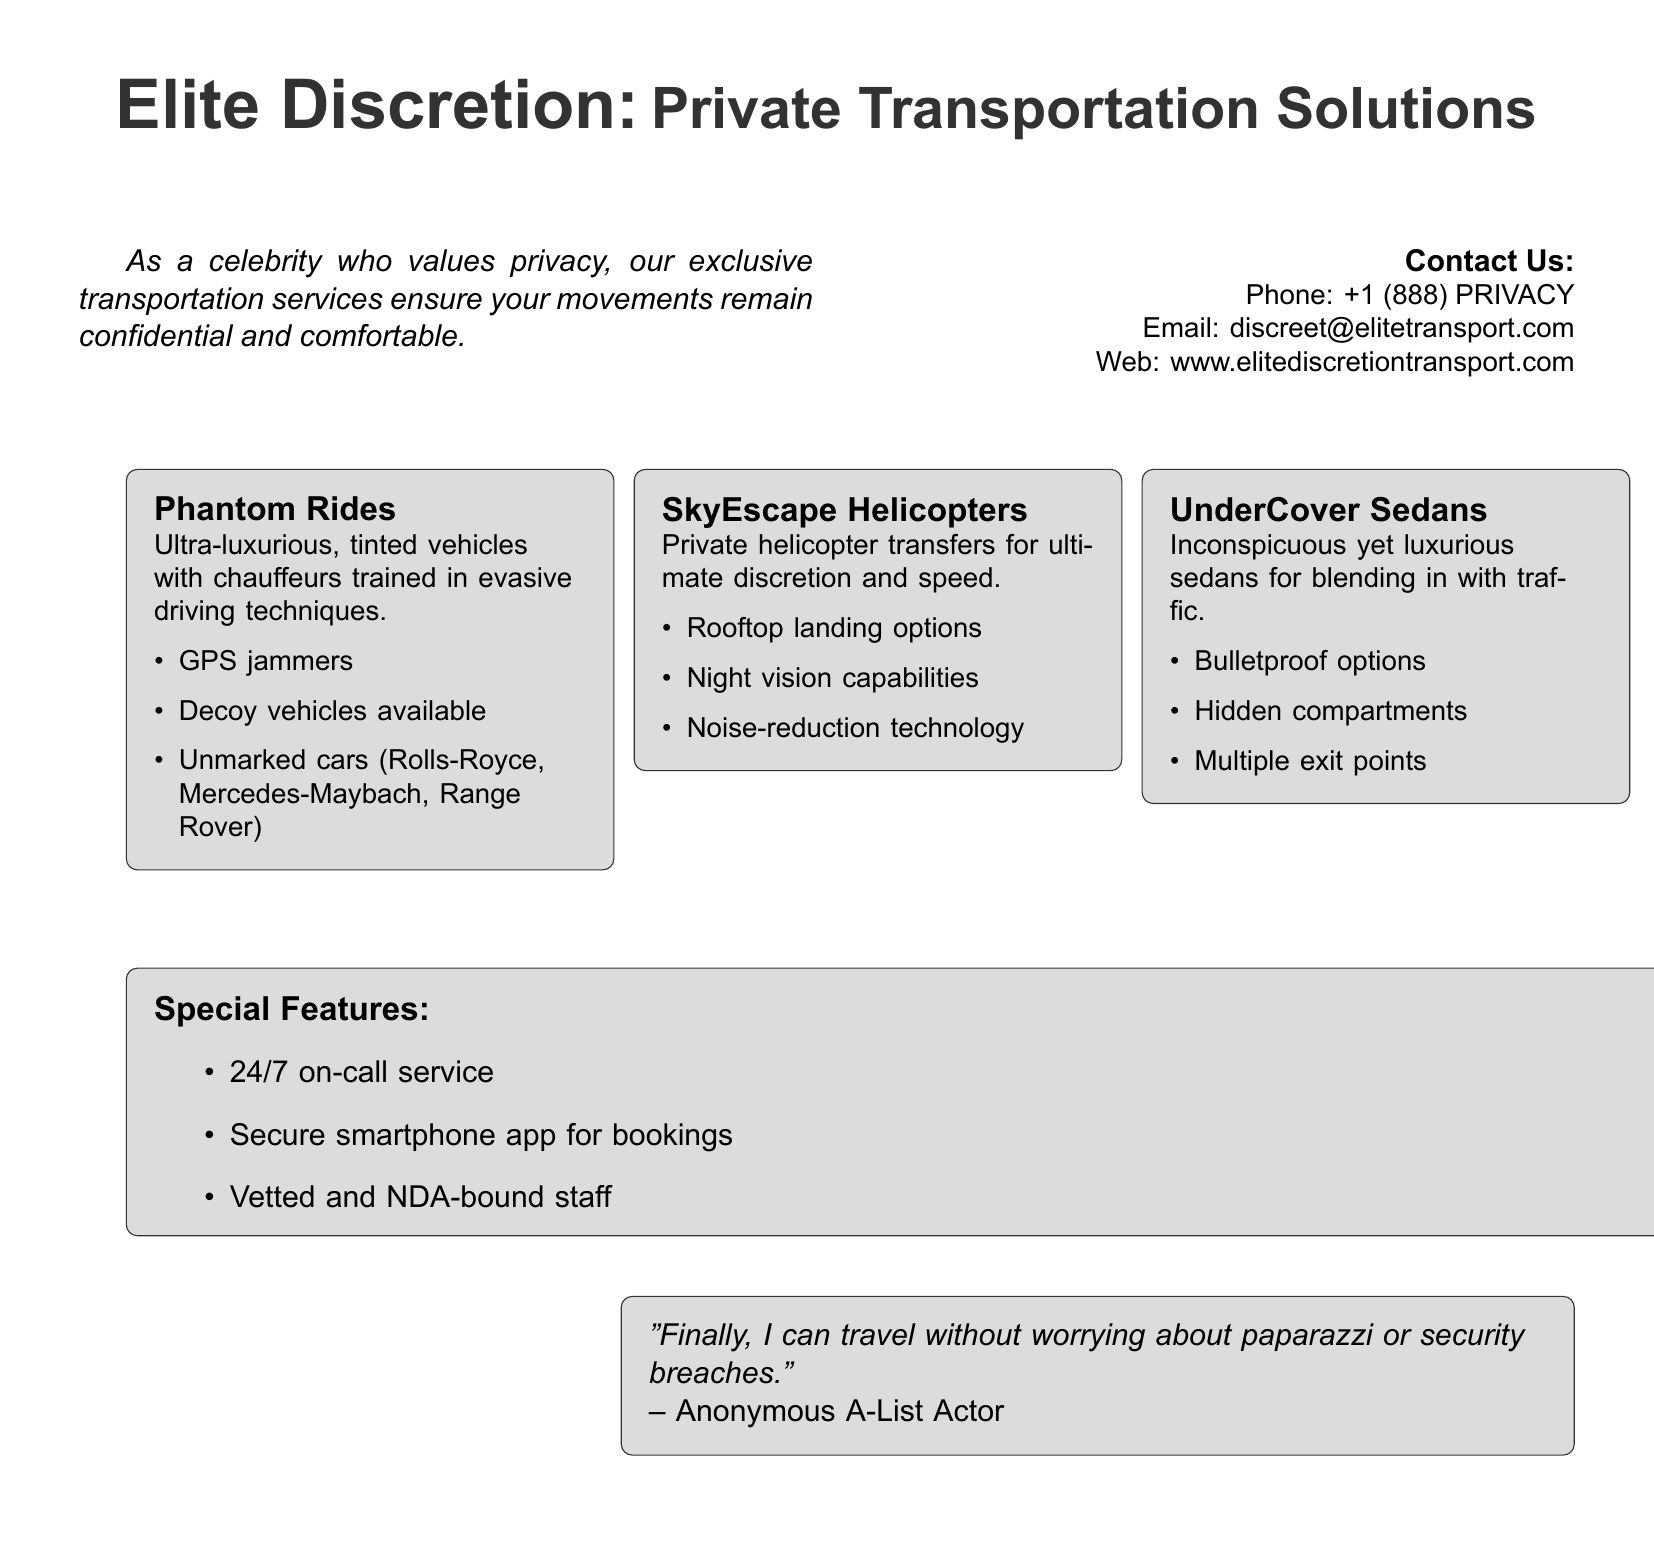What is the name of the transportation service? The name of the transportation service is found at the top of the document, which is "Elite Discretion: Private Transportation Solutions."
Answer: Elite Discretion: Private Transportation Solutions What is the contact phone number provided? The contact phone number is listed under the contact information section in the document.
Answer: +1 (888) PRIVACY What type of vehicles does the Phantom Rides service use? The Phantom Rides service uses ultra-luxurious, tinted vehicles, which include specific brands mentioned in the document.
Answer: Rolls-Royce, Mercedes-Maybach, Range Rover What unique feature does SkyEscape Helicopters offer? The SkyEscape Helicopters service is described with a specific unique feature related to its operational capabilities.
Answer: Rooftop landing options How many primary services are listed in the document? The document lists three primary services in the transportation solutions section.
Answer: 3 What is the special feature of the transportation service available 24/7? The special feature that is available 24/7 is mentioned in the "Special Features" section of the document.
Answer: 24/7 on-call service What is a requirement for the staff mentioned in the document? The document specifies a requirement for the staff that emphasizes confidentiality and trust.
Answer: NDA-bound Which actor is quoted in the document? The document contains a quote attributed to an anonymous actor, highlighting satisfaction with the service.
Answer: Anonymous A-List Actor 